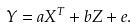<formula> <loc_0><loc_0><loc_500><loc_500>Y = { a } { X } ^ { T } + { b } Z + e .</formula> 